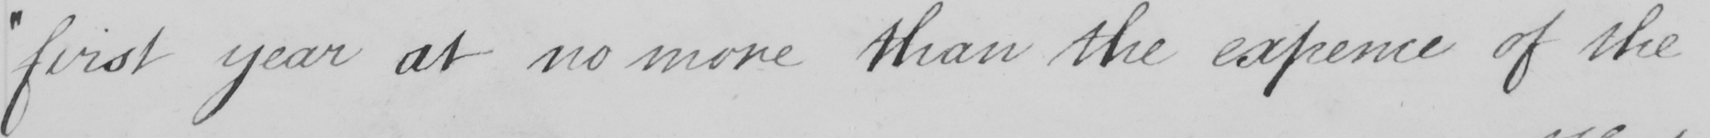Can you read and transcribe this handwriting? " first year at no more than the expence of the 